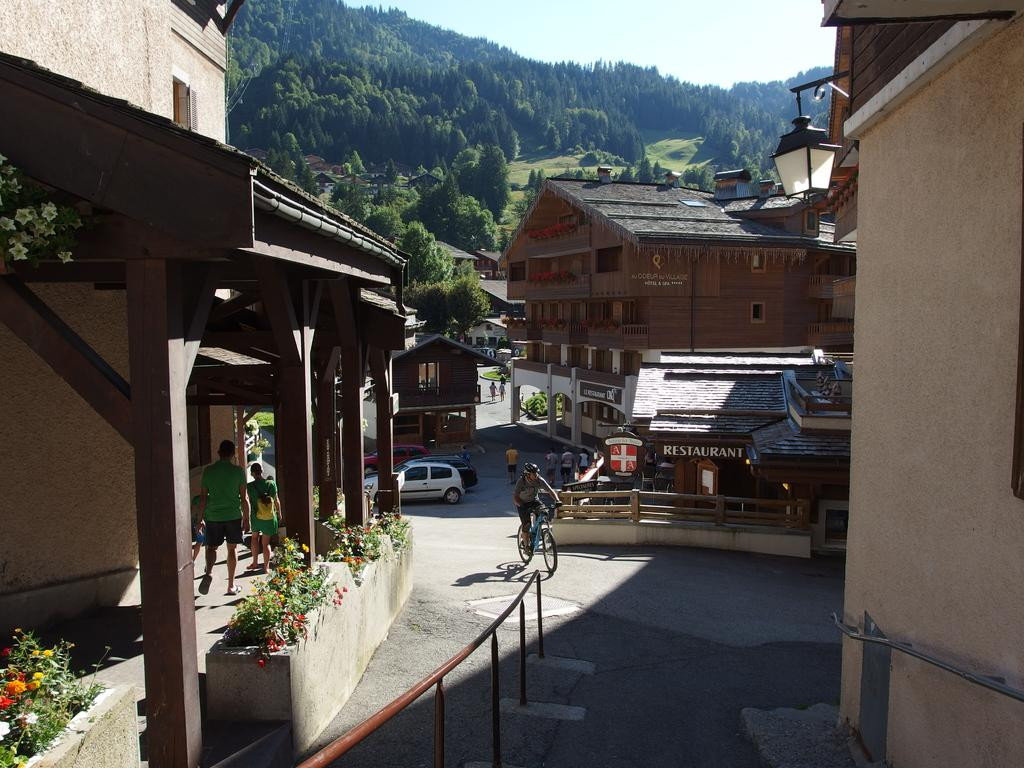<image>
Offer a succinct explanation of the picture presented. The image shows there is a restaurant in this small village area. 